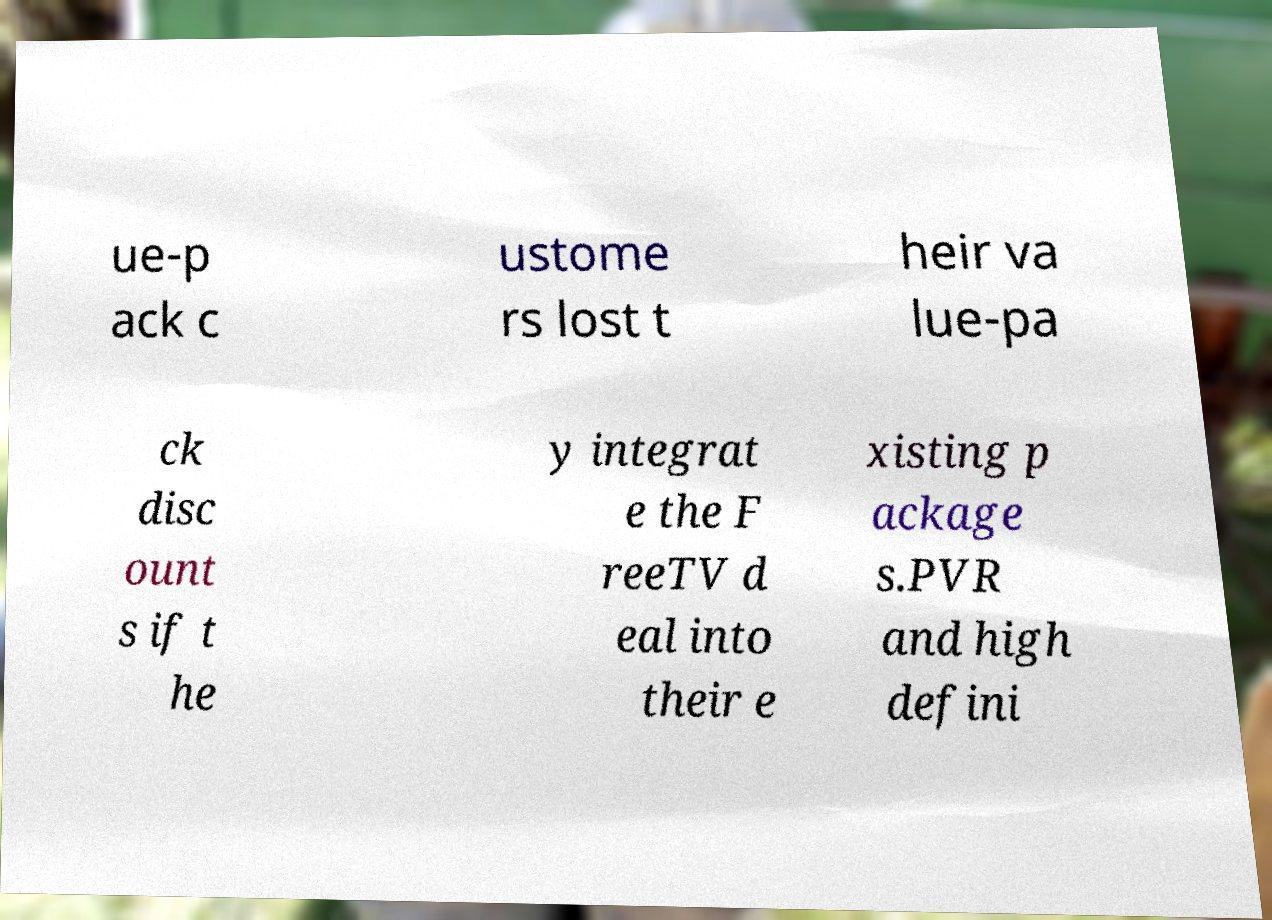Could you extract and type out the text from this image? ue-p ack c ustome rs lost t heir va lue-pa ck disc ount s if t he y integrat e the F reeTV d eal into their e xisting p ackage s.PVR and high defini 